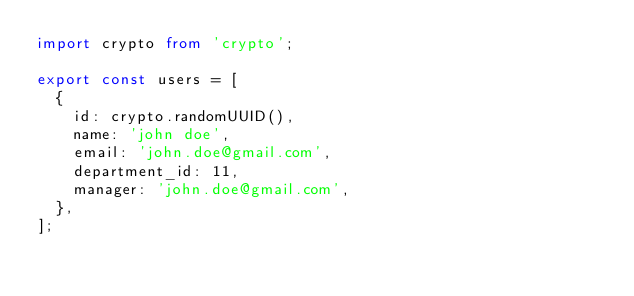Convert code to text. <code><loc_0><loc_0><loc_500><loc_500><_TypeScript_>import crypto from 'crypto';

export const users = [
  {
    id: crypto.randomUUID(),
    name: 'john doe',
    email: 'john.doe@gmail.com',
    department_id: 11,
    manager: 'john.doe@gmail.com',
  },
];
</code> 